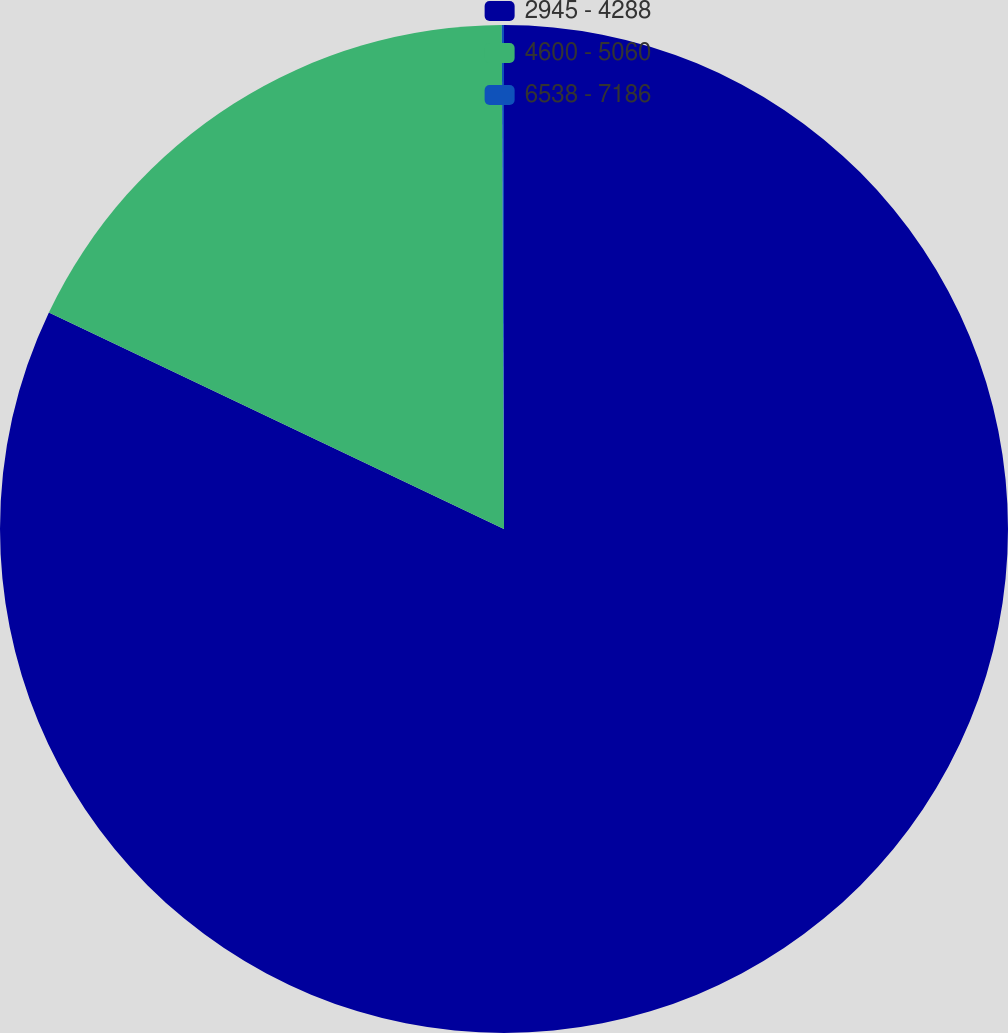<chart> <loc_0><loc_0><loc_500><loc_500><pie_chart><fcel>2945 - 4288<fcel>4600 - 5060<fcel>6538 - 7186<nl><fcel>82.07%<fcel>17.86%<fcel>0.07%<nl></chart> 